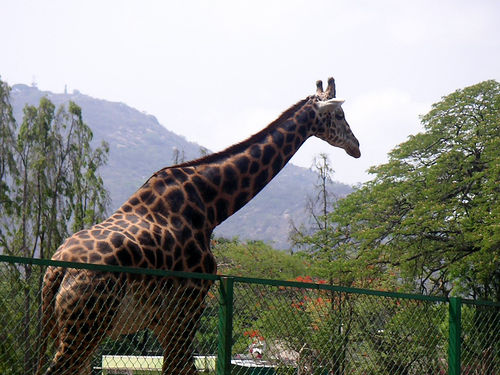What kind of habitat can be seen behind the giraffe? Behind the giraffe is a habitat that includes greenery and trees indicative of a savanna or a grassland environment, with hills in the distance suggesting a semi-open landscape that giraffes often inhabit. 